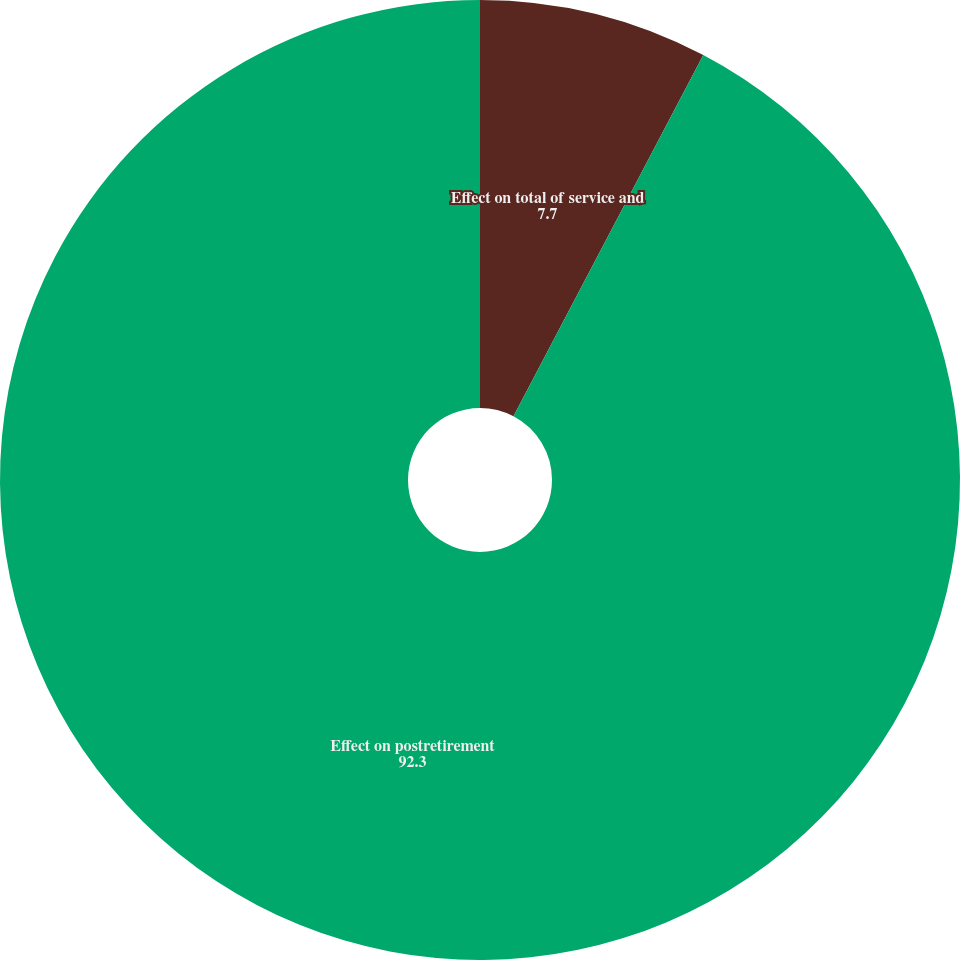<chart> <loc_0><loc_0><loc_500><loc_500><pie_chart><fcel>Effect on total of service and<fcel>Effect on postretirement<nl><fcel>7.7%<fcel>92.3%<nl></chart> 